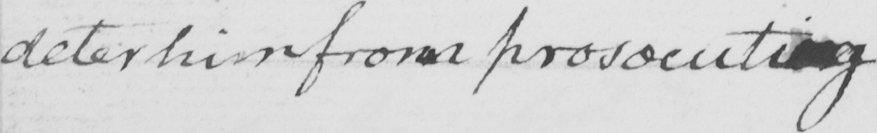What is written in this line of handwriting? deter him from prosecuting . 